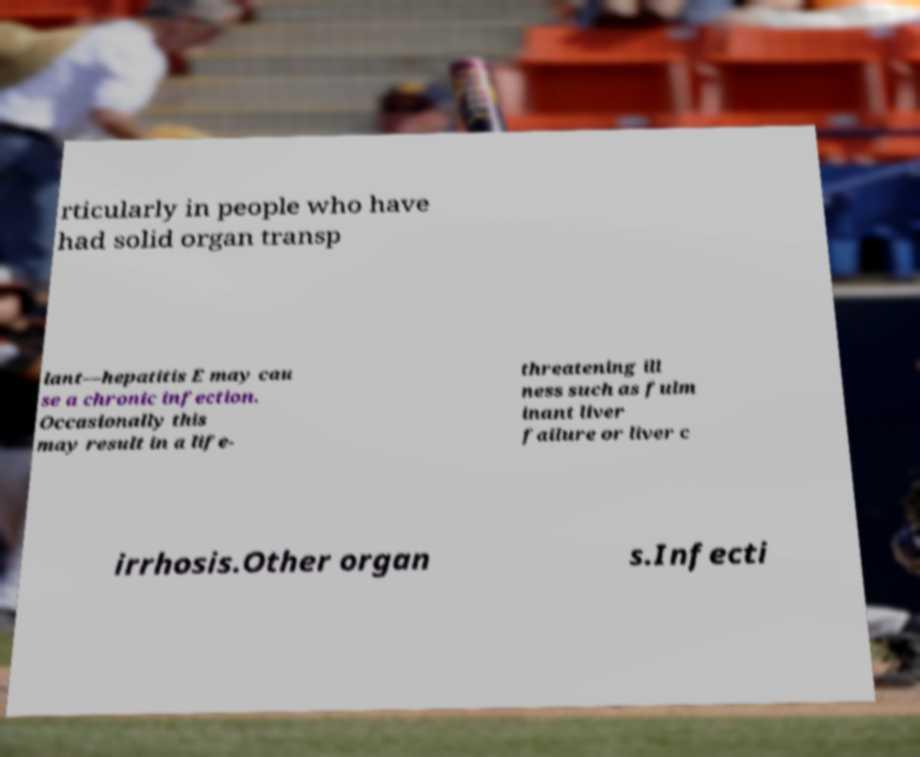For documentation purposes, I need the text within this image transcribed. Could you provide that? rticularly in people who have had solid organ transp lant—hepatitis E may cau se a chronic infection. Occasionally this may result in a life- threatening ill ness such as fulm inant liver failure or liver c irrhosis.Other organ s.Infecti 